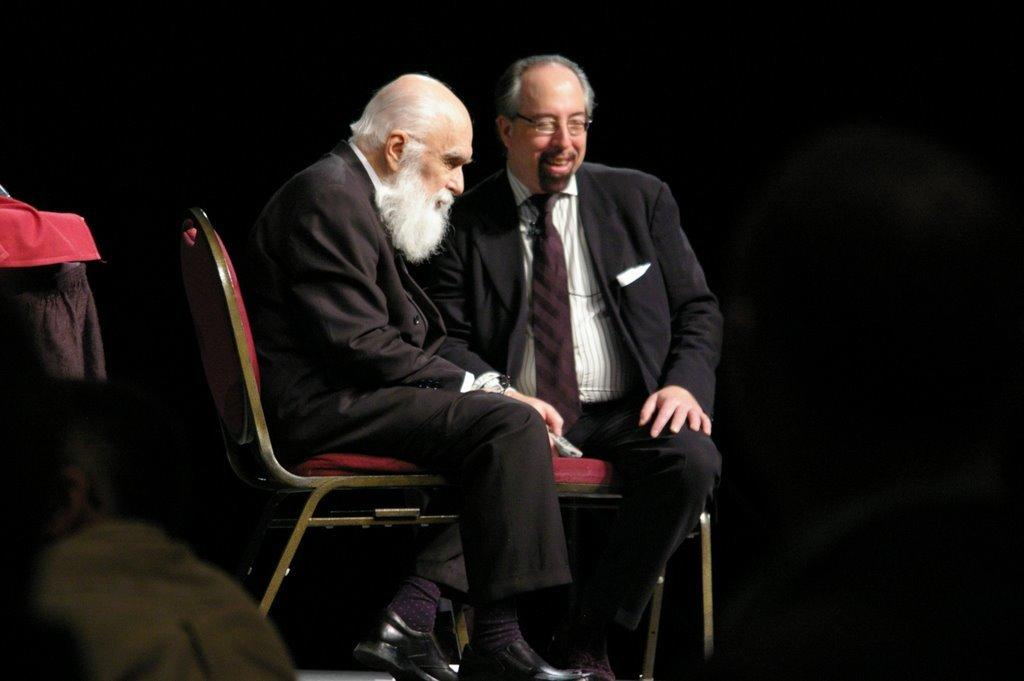How many people are in the image? There are two men in the image. What are the men doing in the image? The men are sitting on chairs. What are the men wearing in the image? Both men are wearing suits. Can you describe any specific features of the men? One of the men is wearing glasses, and one of the men is smiling. What type of food is the squirrel cooking in the image? There is no squirrel or cooking activity present in the image. Can you tell me how many scissors are visible in the image? There are no scissors visible in the image. 